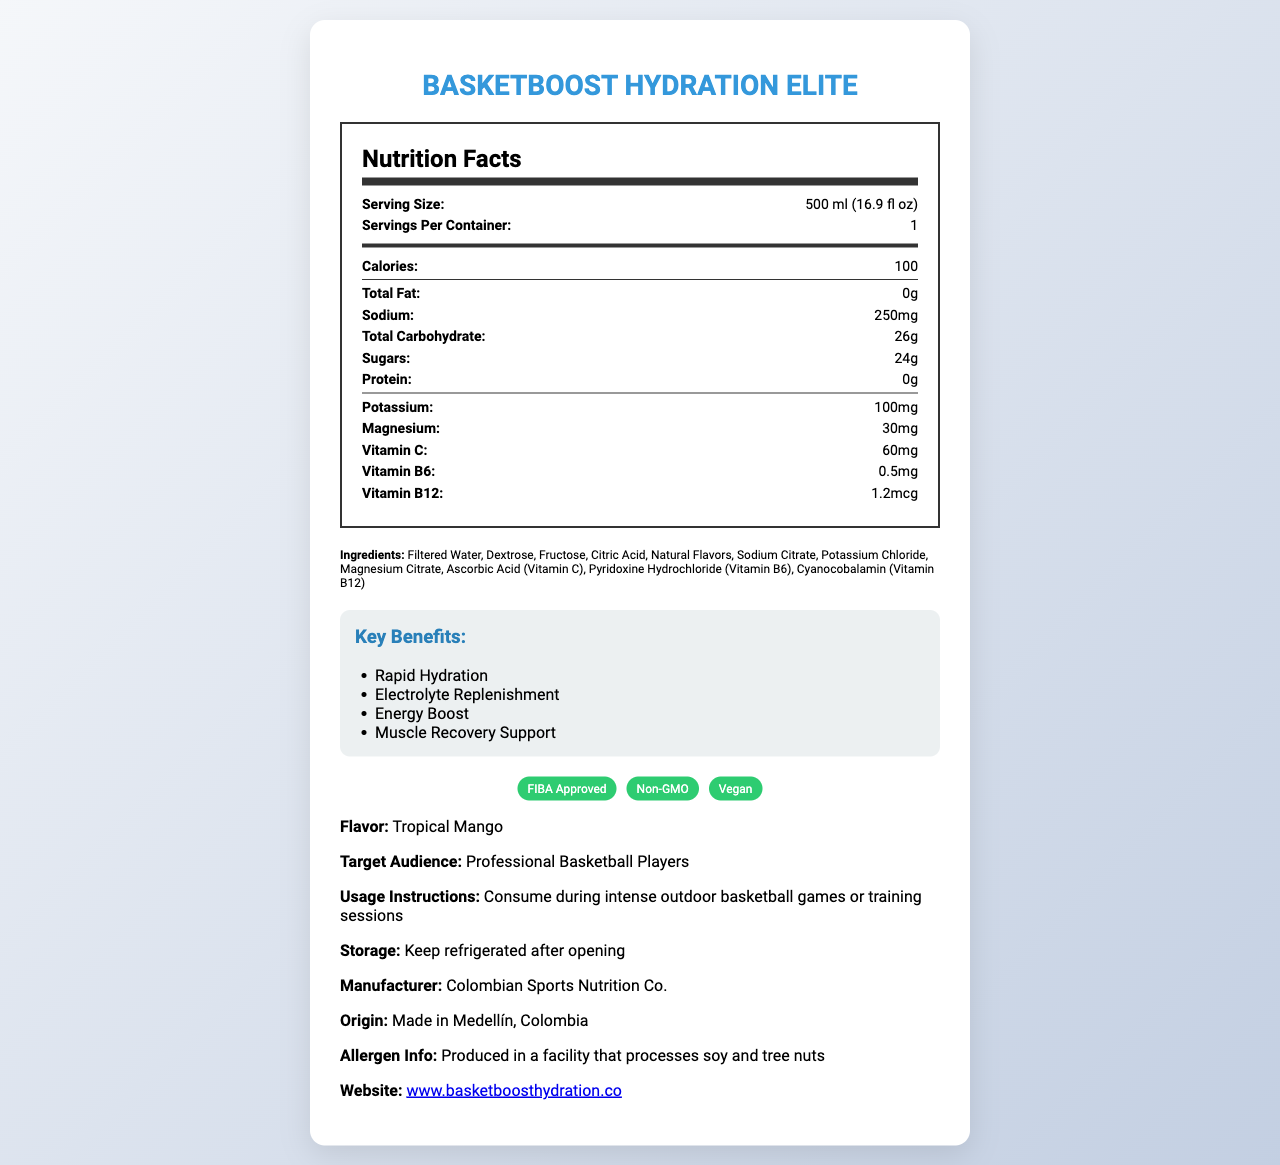what is the serving size? The document specifies the serving size as "500 ml (16.9 fl oz)."
Answer: 500 ml (16.9 fl oz) how many calories are in one serving? The document lists the calories per serving as 100.
Answer: 100 how many grams of total fat does this drink contain? The document specifies that the drink contains 0 grams of total fat.
Answer: 0g what is the amount of sodium in a serving? The document states that there are 250 milligrams of sodium per serving.
Answer: 250mg how much vitamin C is present in the drink? The document lists the amount of vitamin C as 60 milligrams.
Answer: 60mg which of the following is an ingredient in BasketBoost Hydration Elite? A. Aspartame B. Sodium Citrate C. High Fructose Corn Syrup D. Artificial Colors The document includes Sodium Citrate as an ingredient but does not mention Aspartame, High Fructose Corn Syrup, or Artificial Colors.
Answer: B. Sodium Citrate how many grams of sugar are in one serving? A. 20g B. 24g C. 26g D. 30g The document lists the sugar content as 24 grams.
Answer: B. 24g is BasketBoost Hydration Elite vegan? The document mentions that the product is certified "Vegan."
Answer: Yes who is the target audience for this hydration drink? The document states the target audience as "Professional Basketball Players."
Answer: Professional Basketball Players what are the key benefits of BasketBoost Hydration Elite? The document lists the key benefits as Rapid Hydration, Electrolyte Replenishment, Energy Boost, and Muscle Recovery Support.
Answer: Rapid Hydration, Electrolyte Replenishment, Energy Boost, Muscle Recovery Support does the drink contain protein? The document clearly states that the drink contains 0 grams of protein.
Answer: No where is BasketBoost Hydration Elite manufactured? The document specifies that the product is made in Medellín, Colombia.
Answer: Made in Medellín, Colombia does the drink contain magnesium? If yes, what amount? The document lists 30 milligrams of magnesium as one of the nutrients.
Answer: Yes, 30mg what should you do with the drink after opening it? The document advises to "Keep refrigerated after opening."
Answer: Keep refrigerated describe the main idea of the document. The document serves as a comprehensive guide to understanding the nutritional content, benefits, and usage of BasketBoost Hydration Elite, targeting professional basketball players to enhance their performance and recovery.
Answer: The document provides detailed nutrition facts and additional information about BasketBoost Hydration Elite, a hydration drink designed specifically for professional basketball players. It includes information on serving size, calories, nutrient content, ingredients, key benefits, usage instructions, manufacturer details, certifications, and storage guidelines. how much potassium does the drink provide? The document lists 100 milligrams of potassium.
Answer: 100mg is the product FIBA approved? The document includes "FIBA Approved" in its list of certifications.
Answer: Yes does the document provide the company's contact email address? The document does not provide an email address; it only provides the company website URL: www.basketboosthydration.co.
Answer: No 